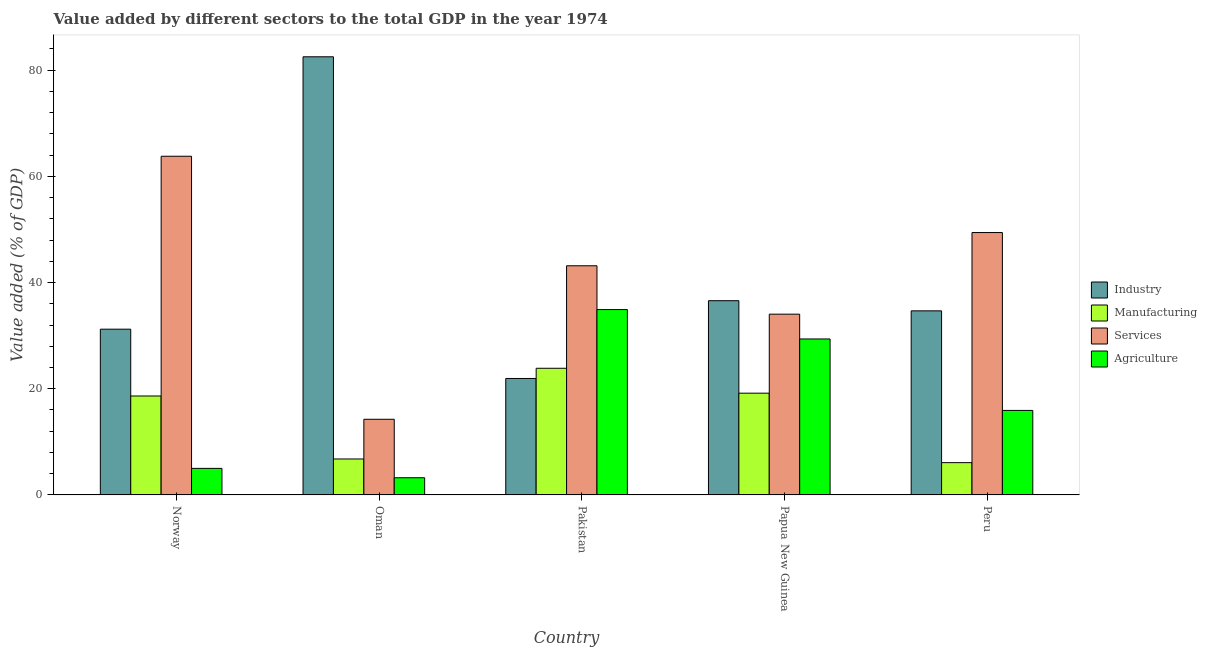How many different coloured bars are there?
Give a very brief answer. 4. Are the number of bars on each tick of the X-axis equal?
Ensure brevity in your answer.  Yes. How many bars are there on the 3rd tick from the left?
Your answer should be very brief. 4. How many bars are there on the 1st tick from the right?
Give a very brief answer. 4. What is the label of the 3rd group of bars from the left?
Your answer should be compact. Pakistan. What is the value added by services sector in Norway?
Your answer should be very brief. 63.79. Across all countries, what is the maximum value added by industrial sector?
Your answer should be very brief. 82.52. Across all countries, what is the minimum value added by industrial sector?
Your answer should be compact. 21.93. In which country was the value added by industrial sector maximum?
Make the answer very short. Oman. What is the total value added by agricultural sector in the graph?
Offer a very short reply. 88.44. What is the difference between the value added by services sector in Norway and that in Oman?
Make the answer very short. 49.54. What is the difference between the value added by industrial sector in Norway and the value added by manufacturing sector in Papua New Guinea?
Make the answer very short. 12.05. What is the average value added by industrial sector per country?
Provide a succinct answer. 41.38. What is the difference between the value added by manufacturing sector and value added by agricultural sector in Pakistan?
Provide a succinct answer. -11.06. What is the ratio of the value added by manufacturing sector in Norway to that in Oman?
Ensure brevity in your answer.  2.75. What is the difference between the highest and the second highest value added by services sector?
Your answer should be very brief. 14.37. What is the difference between the highest and the lowest value added by manufacturing sector?
Keep it short and to the point. 17.77. Is it the case that in every country, the sum of the value added by industrial sector and value added by agricultural sector is greater than the sum of value added by manufacturing sector and value added by services sector?
Your response must be concise. No. What does the 1st bar from the left in Papua New Guinea represents?
Your answer should be compact. Industry. What does the 4th bar from the right in Pakistan represents?
Your answer should be compact. Industry. How many bars are there?
Give a very brief answer. 20. Are all the bars in the graph horizontal?
Your answer should be very brief. No. What is the difference between two consecutive major ticks on the Y-axis?
Offer a very short reply. 20. Does the graph contain any zero values?
Your answer should be compact. No. Where does the legend appear in the graph?
Offer a very short reply. Center right. How are the legend labels stacked?
Provide a succinct answer. Vertical. What is the title of the graph?
Offer a terse response. Value added by different sectors to the total GDP in the year 1974. Does "Periodicity assessment" appear as one of the legend labels in the graph?
Give a very brief answer. No. What is the label or title of the X-axis?
Ensure brevity in your answer.  Country. What is the label or title of the Y-axis?
Keep it short and to the point. Value added (% of GDP). What is the Value added (% of GDP) of Industry in Norway?
Give a very brief answer. 31.22. What is the Value added (% of GDP) of Manufacturing in Norway?
Give a very brief answer. 18.63. What is the Value added (% of GDP) in Services in Norway?
Your answer should be very brief. 63.79. What is the Value added (% of GDP) in Agriculture in Norway?
Your answer should be very brief. 5. What is the Value added (% of GDP) of Industry in Oman?
Give a very brief answer. 82.52. What is the Value added (% of GDP) in Manufacturing in Oman?
Offer a very short reply. 6.77. What is the Value added (% of GDP) of Services in Oman?
Give a very brief answer. 14.25. What is the Value added (% of GDP) of Agriculture in Oman?
Your response must be concise. 3.24. What is the Value added (% of GDP) in Industry in Pakistan?
Provide a short and direct response. 21.93. What is the Value added (% of GDP) in Manufacturing in Pakistan?
Your answer should be very brief. 23.85. What is the Value added (% of GDP) of Services in Pakistan?
Provide a short and direct response. 43.16. What is the Value added (% of GDP) of Agriculture in Pakistan?
Provide a succinct answer. 34.91. What is the Value added (% of GDP) in Industry in Papua New Guinea?
Make the answer very short. 36.58. What is the Value added (% of GDP) of Manufacturing in Papua New Guinea?
Provide a short and direct response. 19.16. What is the Value added (% of GDP) in Services in Papua New Guinea?
Provide a succinct answer. 34.04. What is the Value added (% of GDP) in Agriculture in Papua New Guinea?
Your answer should be compact. 29.37. What is the Value added (% of GDP) in Industry in Peru?
Make the answer very short. 34.67. What is the Value added (% of GDP) of Manufacturing in Peru?
Your answer should be compact. 6.08. What is the Value added (% of GDP) in Services in Peru?
Provide a succinct answer. 49.42. What is the Value added (% of GDP) of Agriculture in Peru?
Provide a short and direct response. 15.92. Across all countries, what is the maximum Value added (% of GDP) of Industry?
Make the answer very short. 82.52. Across all countries, what is the maximum Value added (% of GDP) of Manufacturing?
Your answer should be very brief. 23.85. Across all countries, what is the maximum Value added (% of GDP) in Services?
Ensure brevity in your answer.  63.79. Across all countries, what is the maximum Value added (% of GDP) in Agriculture?
Make the answer very short. 34.91. Across all countries, what is the minimum Value added (% of GDP) in Industry?
Offer a terse response. 21.93. Across all countries, what is the minimum Value added (% of GDP) in Manufacturing?
Ensure brevity in your answer.  6.08. Across all countries, what is the minimum Value added (% of GDP) in Services?
Your answer should be very brief. 14.25. Across all countries, what is the minimum Value added (% of GDP) in Agriculture?
Your answer should be very brief. 3.24. What is the total Value added (% of GDP) in Industry in the graph?
Make the answer very short. 206.91. What is the total Value added (% of GDP) of Manufacturing in the graph?
Your answer should be compact. 74.5. What is the total Value added (% of GDP) of Services in the graph?
Your response must be concise. 204.65. What is the total Value added (% of GDP) of Agriculture in the graph?
Give a very brief answer. 88.44. What is the difference between the Value added (% of GDP) in Industry in Norway and that in Oman?
Make the answer very short. -51.3. What is the difference between the Value added (% of GDP) of Manufacturing in Norway and that in Oman?
Ensure brevity in your answer.  11.86. What is the difference between the Value added (% of GDP) in Services in Norway and that in Oman?
Keep it short and to the point. 49.54. What is the difference between the Value added (% of GDP) in Agriculture in Norway and that in Oman?
Make the answer very short. 1.76. What is the difference between the Value added (% of GDP) of Industry in Norway and that in Pakistan?
Make the answer very short. 9.28. What is the difference between the Value added (% of GDP) in Manufacturing in Norway and that in Pakistan?
Ensure brevity in your answer.  -5.22. What is the difference between the Value added (% of GDP) in Services in Norway and that in Pakistan?
Give a very brief answer. 20.63. What is the difference between the Value added (% of GDP) of Agriculture in Norway and that in Pakistan?
Your answer should be compact. -29.91. What is the difference between the Value added (% of GDP) of Industry in Norway and that in Papua New Guinea?
Provide a succinct answer. -5.36. What is the difference between the Value added (% of GDP) in Manufacturing in Norway and that in Papua New Guinea?
Ensure brevity in your answer.  -0.53. What is the difference between the Value added (% of GDP) of Services in Norway and that in Papua New Guinea?
Give a very brief answer. 29.74. What is the difference between the Value added (% of GDP) of Agriculture in Norway and that in Papua New Guinea?
Offer a very short reply. -24.38. What is the difference between the Value added (% of GDP) in Industry in Norway and that in Peru?
Provide a short and direct response. -3.45. What is the difference between the Value added (% of GDP) in Manufacturing in Norway and that in Peru?
Offer a very short reply. 12.55. What is the difference between the Value added (% of GDP) in Services in Norway and that in Peru?
Keep it short and to the point. 14.37. What is the difference between the Value added (% of GDP) of Agriculture in Norway and that in Peru?
Your answer should be compact. -10.92. What is the difference between the Value added (% of GDP) of Industry in Oman and that in Pakistan?
Your answer should be compact. 60.58. What is the difference between the Value added (% of GDP) of Manufacturing in Oman and that in Pakistan?
Offer a very short reply. -17.08. What is the difference between the Value added (% of GDP) in Services in Oman and that in Pakistan?
Offer a terse response. -28.91. What is the difference between the Value added (% of GDP) in Agriculture in Oman and that in Pakistan?
Offer a terse response. -31.68. What is the difference between the Value added (% of GDP) of Industry in Oman and that in Papua New Guinea?
Ensure brevity in your answer.  45.94. What is the difference between the Value added (% of GDP) of Manufacturing in Oman and that in Papua New Guinea?
Your answer should be very brief. -12.39. What is the difference between the Value added (% of GDP) in Services in Oman and that in Papua New Guinea?
Keep it short and to the point. -19.8. What is the difference between the Value added (% of GDP) in Agriculture in Oman and that in Papua New Guinea?
Give a very brief answer. -26.14. What is the difference between the Value added (% of GDP) of Industry in Oman and that in Peru?
Make the answer very short. 47.85. What is the difference between the Value added (% of GDP) in Manufacturing in Oman and that in Peru?
Your response must be concise. 0.69. What is the difference between the Value added (% of GDP) in Services in Oman and that in Peru?
Provide a succinct answer. -35.17. What is the difference between the Value added (% of GDP) of Agriculture in Oman and that in Peru?
Offer a very short reply. -12.68. What is the difference between the Value added (% of GDP) of Industry in Pakistan and that in Papua New Guinea?
Give a very brief answer. -14.65. What is the difference between the Value added (% of GDP) of Manufacturing in Pakistan and that in Papua New Guinea?
Provide a succinct answer. 4.69. What is the difference between the Value added (% of GDP) in Services in Pakistan and that in Papua New Guinea?
Give a very brief answer. 9.11. What is the difference between the Value added (% of GDP) of Agriculture in Pakistan and that in Papua New Guinea?
Your response must be concise. 5.54. What is the difference between the Value added (% of GDP) in Industry in Pakistan and that in Peru?
Give a very brief answer. -12.74. What is the difference between the Value added (% of GDP) in Manufacturing in Pakistan and that in Peru?
Your answer should be very brief. 17.77. What is the difference between the Value added (% of GDP) in Services in Pakistan and that in Peru?
Provide a short and direct response. -6.26. What is the difference between the Value added (% of GDP) in Agriculture in Pakistan and that in Peru?
Your answer should be very brief. 19. What is the difference between the Value added (% of GDP) of Industry in Papua New Guinea and that in Peru?
Offer a very short reply. 1.91. What is the difference between the Value added (% of GDP) in Manufacturing in Papua New Guinea and that in Peru?
Your answer should be very brief. 13.08. What is the difference between the Value added (% of GDP) of Services in Papua New Guinea and that in Peru?
Ensure brevity in your answer.  -15.37. What is the difference between the Value added (% of GDP) of Agriculture in Papua New Guinea and that in Peru?
Your answer should be compact. 13.46. What is the difference between the Value added (% of GDP) of Industry in Norway and the Value added (% of GDP) of Manufacturing in Oman?
Offer a terse response. 24.45. What is the difference between the Value added (% of GDP) of Industry in Norway and the Value added (% of GDP) of Services in Oman?
Make the answer very short. 16.97. What is the difference between the Value added (% of GDP) in Industry in Norway and the Value added (% of GDP) in Agriculture in Oman?
Ensure brevity in your answer.  27.98. What is the difference between the Value added (% of GDP) in Manufacturing in Norway and the Value added (% of GDP) in Services in Oman?
Give a very brief answer. 4.39. What is the difference between the Value added (% of GDP) of Manufacturing in Norway and the Value added (% of GDP) of Agriculture in Oman?
Ensure brevity in your answer.  15.4. What is the difference between the Value added (% of GDP) of Services in Norway and the Value added (% of GDP) of Agriculture in Oman?
Keep it short and to the point. 60.55. What is the difference between the Value added (% of GDP) of Industry in Norway and the Value added (% of GDP) of Manufacturing in Pakistan?
Give a very brief answer. 7.36. What is the difference between the Value added (% of GDP) of Industry in Norway and the Value added (% of GDP) of Services in Pakistan?
Provide a short and direct response. -11.94. What is the difference between the Value added (% of GDP) of Industry in Norway and the Value added (% of GDP) of Agriculture in Pakistan?
Provide a succinct answer. -3.7. What is the difference between the Value added (% of GDP) of Manufacturing in Norway and the Value added (% of GDP) of Services in Pakistan?
Make the answer very short. -24.52. What is the difference between the Value added (% of GDP) in Manufacturing in Norway and the Value added (% of GDP) in Agriculture in Pakistan?
Ensure brevity in your answer.  -16.28. What is the difference between the Value added (% of GDP) of Services in Norway and the Value added (% of GDP) of Agriculture in Pakistan?
Your answer should be very brief. 28.87. What is the difference between the Value added (% of GDP) of Industry in Norway and the Value added (% of GDP) of Manufacturing in Papua New Guinea?
Keep it short and to the point. 12.05. What is the difference between the Value added (% of GDP) in Industry in Norway and the Value added (% of GDP) in Services in Papua New Guinea?
Your answer should be compact. -2.83. What is the difference between the Value added (% of GDP) of Industry in Norway and the Value added (% of GDP) of Agriculture in Papua New Guinea?
Provide a short and direct response. 1.84. What is the difference between the Value added (% of GDP) in Manufacturing in Norway and the Value added (% of GDP) in Services in Papua New Guinea?
Make the answer very short. -15.41. What is the difference between the Value added (% of GDP) of Manufacturing in Norway and the Value added (% of GDP) of Agriculture in Papua New Guinea?
Your answer should be compact. -10.74. What is the difference between the Value added (% of GDP) of Services in Norway and the Value added (% of GDP) of Agriculture in Papua New Guinea?
Your answer should be compact. 34.41. What is the difference between the Value added (% of GDP) of Industry in Norway and the Value added (% of GDP) of Manufacturing in Peru?
Provide a succinct answer. 25.14. What is the difference between the Value added (% of GDP) in Industry in Norway and the Value added (% of GDP) in Services in Peru?
Offer a very short reply. -18.2. What is the difference between the Value added (% of GDP) of Industry in Norway and the Value added (% of GDP) of Agriculture in Peru?
Provide a short and direct response. 15.3. What is the difference between the Value added (% of GDP) of Manufacturing in Norway and the Value added (% of GDP) of Services in Peru?
Give a very brief answer. -30.78. What is the difference between the Value added (% of GDP) in Manufacturing in Norway and the Value added (% of GDP) in Agriculture in Peru?
Your response must be concise. 2.72. What is the difference between the Value added (% of GDP) of Services in Norway and the Value added (% of GDP) of Agriculture in Peru?
Ensure brevity in your answer.  47.87. What is the difference between the Value added (% of GDP) in Industry in Oman and the Value added (% of GDP) in Manufacturing in Pakistan?
Keep it short and to the point. 58.66. What is the difference between the Value added (% of GDP) of Industry in Oman and the Value added (% of GDP) of Services in Pakistan?
Provide a succinct answer. 39.36. What is the difference between the Value added (% of GDP) in Industry in Oman and the Value added (% of GDP) in Agriculture in Pakistan?
Make the answer very short. 47.6. What is the difference between the Value added (% of GDP) of Manufacturing in Oman and the Value added (% of GDP) of Services in Pakistan?
Keep it short and to the point. -36.39. What is the difference between the Value added (% of GDP) of Manufacturing in Oman and the Value added (% of GDP) of Agriculture in Pakistan?
Your response must be concise. -28.14. What is the difference between the Value added (% of GDP) in Services in Oman and the Value added (% of GDP) in Agriculture in Pakistan?
Your answer should be very brief. -20.66. What is the difference between the Value added (% of GDP) of Industry in Oman and the Value added (% of GDP) of Manufacturing in Papua New Guinea?
Give a very brief answer. 63.35. What is the difference between the Value added (% of GDP) of Industry in Oman and the Value added (% of GDP) of Services in Papua New Guinea?
Give a very brief answer. 48.47. What is the difference between the Value added (% of GDP) in Industry in Oman and the Value added (% of GDP) in Agriculture in Papua New Guinea?
Offer a very short reply. 53.14. What is the difference between the Value added (% of GDP) in Manufacturing in Oman and the Value added (% of GDP) in Services in Papua New Guinea?
Your answer should be very brief. -27.27. What is the difference between the Value added (% of GDP) of Manufacturing in Oman and the Value added (% of GDP) of Agriculture in Papua New Guinea?
Make the answer very short. -22.6. What is the difference between the Value added (% of GDP) in Services in Oman and the Value added (% of GDP) in Agriculture in Papua New Guinea?
Offer a very short reply. -15.13. What is the difference between the Value added (% of GDP) of Industry in Oman and the Value added (% of GDP) of Manufacturing in Peru?
Your answer should be compact. 76.44. What is the difference between the Value added (% of GDP) of Industry in Oman and the Value added (% of GDP) of Services in Peru?
Your response must be concise. 33.1. What is the difference between the Value added (% of GDP) in Industry in Oman and the Value added (% of GDP) in Agriculture in Peru?
Provide a short and direct response. 66.6. What is the difference between the Value added (% of GDP) of Manufacturing in Oman and the Value added (% of GDP) of Services in Peru?
Your answer should be very brief. -42.65. What is the difference between the Value added (% of GDP) in Manufacturing in Oman and the Value added (% of GDP) in Agriculture in Peru?
Provide a short and direct response. -9.15. What is the difference between the Value added (% of GDP) of Services in Oman and the Value added (% of GDP) of Agriculture in Peru?
Provide a succinct answer. -1.67. What is the difference between the Value added (% of GDP) in Industry in Pakistan and the Value added (% of GDP) in Manufacturing in Papua New Guinea?
Keep it short and to the point. 2.77. What is the difference between the Value added (% of GDP) in Industry in Pakistan and the Value added (% of GDP) in Services in Papua New Guinea?
Provide a succinct answer. -12.11. What is the difference between the Value added (% of GDP) of Industry in Pakistan and the Value added (% of GDP) of Agriculture in Papua New Guinea?
Give a very brief answer. -7.44. What is the difference between the Value added (% of GDP) in Manufacturing in Pakistan and the Value added (% of GDP) in Services in Papua New Guinea?
Offer a very short reply. -10.19. What is the difference between the Value added (% of GDP) of Manufacturing in Pakistan and the Value added (% of GDP) of Agriculture in Papua New Guinea?
Give a very brief answer. -5.52. What is the difference between the Value added (% of GDP) of Services in Pakistan and the Value added (% of GDP) of Agriculture in Papua New Guinea?
Offer a terse response. 13.78. What is the difference between the Value added (% of GDP) in Industry in Pakistan and the Value added (% of GDP) in Manufacturing in Peru?
Make the answer very short. 15.85. What is the difference between the Value added (% of GDP) in Industry in Pakistan and the Value added (% of GDP) in Services in Peru?
Ensure brevity in your answer.  -27.48. What is the difference between the Value added (% of GDP) in Industry in Pakistan and the Value added (% of GDP) in Agriculture in Peru?
Ensure brevity in your answer.  6.02. What is the difference between the Value added (% of GDP) in Manufacturing in Pakistan and the Value added (% of GDP) in Services in Peru?
Ensure brevity in your answer.  -25.56. What is the difference between the Value added (% of GDP) in Manufacturing in Pakistan and the Value added (% of GDP) in Agriculture in Peru?
Offer a very short reply. 7.94. What is the difference between the Value added (% of GDP) of Services in Pakistan and the Value added (% of GDP) of Agriculture in Peru?
Provide a succinct answer. 27.24. What is the difference between the Value added (% of GDP) in Industry in Papua New Guinea and the Value added (% of GDP) in Manufacturing in Peru?
Keep it short and to the point. 30.5. What is the difference between the Value added (% of GDP) of Industry in Papua New Guinea and the Value added (% of GDP) of Services in Peru?
Provide a succinct answer. -12.84. What is the difference between the Value added (% of GDP) in Industry in Papua New Guinea and the Value added (% of GDP) in Agriculture in Peru?
Your answer should be compact. 20.66. What is the difference between the Value added (% of GDP) of Manufacturing in Papua New Guinea and the Value added (% of GDP) of Services in Peru?
Your response must be concise. -30.25. What is the difference between the Value added (% of GDP) of Manufacturing in Papua New Guinea and the Value added (% of GDP) of Agriculture in Peru?
Offer a terse response. 3.25. What is the difference between the Value added (% of GDP) in Services in Papua New Guinea and the Value added (% of GDP) in Agriculture in Peru?
Your answer should be compact. 18.13. What is the average Value added (% of GDP) in Industry per country?
Make the answer very short. 41.38. What is the average Value added (% of GDP) in Manufacturing per country?
Ensure brevity in your answer.  14.9. What is the average Value added (% of GDP) in Services per country?
Make the answer very short. 40.93. What is the average Value added (% of GDP) of Agriculture per country?
Your answer should be compact. 17.69. What is the difference between the Value added (% of GDP) in Industry and Value added (% of GDP) in Manufacturing in Norway?
Make the answer very short. 12.58. What is the difference between the Value added (% of GDP) of Industry and Value added (% of GDP) of Services in Norway?
Make the answer very short. -32.57. What is the difference between the Value added (% of GDP) of Industry and Value added (% of GDP) of Agriculture in Norway?
Offer a terse response. 26.22. What is the difference between the Value added (% of GDP) in Manufacturing and Value added (% of GDP) in Services in Norway?
Your answer should be compact. -45.15. What is the difference between the Value added (% of GDP) in Manufacturing and Value added (% of GDP) in Agriculture in Norway?
Provide a short and direct response. 13.63. What is the difference between the Value added (% of GDP) of Services and Value added (% of GDP) of Agriculture in Norway?
Offer a very short reply. 58.79. What is the difference between the Value added (% of GDP) of Industry and Value added (% of GDP) of Manufacturing in Oman?
Provide a short and direct response. 75.75. What is the difference between the Value added (% of GDP) of Industry and Value added (% of GDP) of Services in Oman?
Your answer should be compact. 68.27. What is the difference between the Value added (% of GDP) in Industry and Value added (% of GDP) in Agriculture in Oman?
Provide a succinct answer. 79.28. What is the difference between the Value added (% of GDP) of Manufacturing and Value added (% of GDP) of Services in Oman?
Offer a terse response. -7.48. What is the difference between the Value added (% of GDP) of Manufacturing and Value added (% of GDP) of Agriculture in Oman?
Offer a very short reply. 3.53. What is the difference between the Value added (% of GDP) in Services and Value added (% of GDP) in Agriculture in Oman?
Provide a succinct answer. 11.01. What is the difference between the Value added (% of GDP) of Industry and Value added (% of GDP) of Manufacturing in Pakistan?
Provide a short and direct response. -1.92. What is the difference between the Value added (% of GDP) in Industry and Value added (% of GDP) in Services in Pakistan?
Ensure brevity in your answer.  -21.22. What is the difference between the Value added (% of GDP) in Industry and Value added (% of GDP) in Agriculture in Pakistan?
Make the answer very short. -12.98. What is the difference between the Value added (% of GDP) of Manufacturing and Value added (% of GDP) of Services in Pakistan?
Offer a very short reply. -19.3. What is the difference between the Value added (% of GDP) in Manufacturing and Value added (% of GDP) in Agriculture in Pakistan?
Provide a short and direct response. -11.06. What is the difference between the Value added (% of GDP) of Services and Value added (% of GDP) of Agriculture in Pakistan?
Your answer should be compact. 8.24. What is the difference between the Value added (% of GDP) of Industry and Value added (% of GDP) of Manufacturing in Papua New Guinea?
Offer a terse response. 17.42. What is the difference between the Value added (% of GDP) of Industry and Value added (% of GDP) of Services in Papua New Guinea?
Provide a short and direct response. 2.54. What is the difference between the Value added (% of GDP) of Industry and Value added (% of GDP) of Agriculture in Papua New Guinea?
Provide a succinct answer. 7.21. What is the difference between the Value added (% of GDP) in Manufacturing and Value added (% of GDP) in Services in Papua New Guinea?
Give a very brief answer. -14.88. What is the difference between the Value added (% of GDP) of Manufacturing and Value added (% of GDP) of Agriculture in Papua New Guinea?
Provide a succinct answer. -10.21. What is the difference between the Value added (% of GDP) in Services and Value added (% of GDP) in Agriculture in Papua New Guinea?
Make the answer very short. 4.67. What is the difference between the Value added (% of GDP) in Industry and Value added (% of GDP) in Manufacturing in Peru?
Ensure brevity in your answer.  28.59. What is the difference between the Value added (% of GDP) in Industry and Value added (% of GDP) in Services in Peru?
Keep it short and to the point. -14.75. What is the difference between the Value added (% of GDP) of Industry and Value added (% of GDP) of Agriculture in Peru?
Offer a terse response. 18.75. What is the difference between the Value added (% of GDP) of Manufacturing and Value added (% of GDP) of Services in Peru?
Provide a short and direct response. -43.34. What is the difference between the Value added (% of GDP) in Manufacturing and Value added (% of GDP) in Agriculture in Peru?
Provide a succinct answer. -9.84. What is the difference between the Value added (% of GDP) in Services and Value added (% of GDP) in Agriculture in Peru?
Give a very brief answer. 33.5. What is the ratio of the Value added (% of GDP) in Industry in Norway to that in Oman?
Give a very brief answer. 0.38. What is the ratio of the Value added (% of GDP) of Manufacturing in Norway to that in Oman?
Offer a terse response. 2.75. What is the ratio of the Value added (% of GDP) in Services in Norway to that in Oman?
Give a very brief answer. 4.48. What is the ratio of the Value added (% of GDP) in Agriculture in Norway to that in Oman?
Ensure brevity in your answer.  1.54. What is the ratio of the Value added (% of GDP) of Industry in Norway to that in Pakistan?
Provide a short and direct response. 1.42. What is the ratio of the Value added (% of GDP) in Manufacturing in Norway to that in Pakistan?
Keep it short and to the point. 0.78. What is the ratio of the Value added (% of GDP) in Services in Norway to that in Pakistan?
Keep it short and to the point. 1.48. What is the ratio of the Value added (% of GDP) of Agriculture in Norway to that in Pakistan?
Provide a short and direct response. 0.14. What is the ratio of the Value added (% of GDP) in Industry in Norway to that in Papua New Guinea?
Give a very brief answer. 0.85. What is the ratio of the Value added (% of GDP) of Manufacturing in Norway to that in Papua New Guinea?
Make the answer very short. 0.97. What is the ratio of the Value added (% of GDP) in Services in Norway to that in Papua New Guinea?
Your answer should be compact. 1.87. What is the ratio of the Value added (% of GDP) in Agriculture in Norway to that in Papua New Guinea?
Ensure brevity in your answer.  0.17. What is the ratio of the Value added (% of GDP) in Industry in Norway to that in Peru?
Provide a succinct answer. 0.9. What is the ratio of the Value added (% of GDP) of Manufacturing in Norway to that in Peru?
Keep it short and to the point. 3.07. What is the ratio of the Value added (% of GDP) in Services in Norway to that in Peru?
Provide a succinct answer. 1.29. What is the ratio of the Value added (% of GDP) in Agriculture in Norway to that in Peru?
Keep it short and to the point. 0.31. What is the ratio of the Value added (% of GDP) of Industry in Oman to that in Pakistan?
Offer a very short reply. 3.76. What is the ratio of the Value added (% of GDP) of Manufacturing in Oman to that in Pakistan?
Your response must be concise. 0.28. What is the ratio of the Value added (% of GDP) of Services in Oman to that in Pakistan?
Your answer should be very brief. 0.33. What is the ratio of the Value added (% of GDP) of Agriculture in Oman to that in Pakistan?
Your answer should be very brief. 0.09. What is the ratio of the Value added (% of GDP) of Industry in Oman to that in Papua New Guinea?
Provide a short and direct response. 2.26. What is the ratio of the Value added (% of GDP) of Manufacturing in Oman to that in Papua New Guinea?
Your answer should be very brief. 0.35. What is the ratio of the Value added (% of GDP) of Services in Oman to that in Papua New Guinea?
Your answer should be compact. 0.42. What is the ratio of the Value added (% of GDP) in Agriculture in Oman to that in Papua New Guinea?
Provide a succinct answer. 0.11. What is the ratio of the Value added (% of GDP) of Industry in Oman to that in Peru?
Provide a short and direct response. 2.38. What is the ratio of the Value added (% of GDP) of Manufacturing in Oman to that in Peru?
Offer a terse response. 1.11. What is the ratio of the Value added (% of GDP) in Services in Oman to that in Peru?
Make the answer very short. 0.29. What is the ratio of the Value added (% of GDP) of Agriculture in Oman to that in Peru?
Provide a succinct answer. 0.2. What is the ratio of the Value added (% of GDP) in Industry in Pakistan to that in Papua New Guinea?
Provide a short and direct response. 0.6. What is the ratio of the Value added (% of GDP) of Manufacturing in Pakistan to that in Papua New Guinea?
Ensure brevity in your answer.  1.24. What is the ratio of the Value added (% of GDP) in Services in Pakistan to that in Papua New Guinea?
Offer a terse response. 1.27. What is the ratio of the Value added (% of GDP) of Agriculture in Pakistan to that in Papua New Guinea?
Your response must be concise. 1.19. What is the ratio of the Value added (% of GDP) of Industry in Pakistan to that in Peru?
Keep it short and to the point. 0.63. What is the ratio of the Value added (% of GDP) of Manufacturing in Pakistan to that in Peru?
Provide a short and direct response. 3.92. What is the ratio of the Value added (% of GDP) of Services in Pakistan to that in Peru?
Provide a succinct answer. 0.87. What is the ratio of the Value added (% of GDP) in Agriculture in Pakistan to that in Peru?
Keep it short and to the point. 2.19. What is the ratio of the Value added (% of GDP) of Industry in Papua New Guinea to that in Peru?
Your answer should be compact. 1.06. What is the ratio of the Value added (% of GDP) of Manufacturing in Papua New Guinea to that in Peru?
Provide a short and direct response. 3.15. What is the ratio of the Value added (% of GDP) in Services in Papua New Guinea to that in Peru?
Provide a short and direct response. 0.69. What is the ratio of the Value added (% of GDP) of Agriculture in Papua New Guinea to that in Peru?
Keep it short and to the point. 1.85. What is the difference between the highest and the second highest Value added (% of GDP) in Industry?
Give a very brief answer. 45.94. What is the difference between the highest and the second highest Value added (% of GDP) of Manufacturing?
Make the answer very short. 4.69. What is the difference between the highest and the second highest Value added (% of GDP) in Services?
Offer a terse response. 14.37. What is the difference between the highest and the second highest Value added (% of GDP) in Agriculture?
Offer a very short reply. 5.54. What is the difference between the highest and the lowest Value added (% of GDP) of Industry?
Your answer should be very brief. 60.58. What is the difference between the highest and the lowest Value added (% of GDP) of Manufacturing?
Provide a succinct answer. 17.77. What is the difference between the highest and the lowest Value added (% of GDP) of Services?
Your answer should be compact. 49.54. What is the difference between the highest and the lowest Value added (% of GDP) of Agriculture?
Provide a succinct answer. 31.68. 